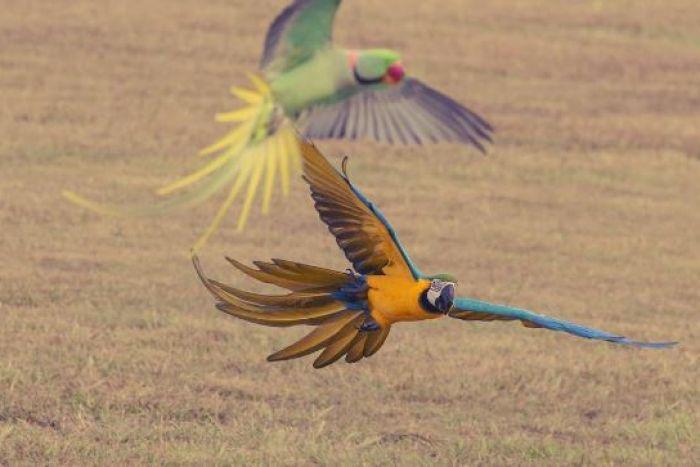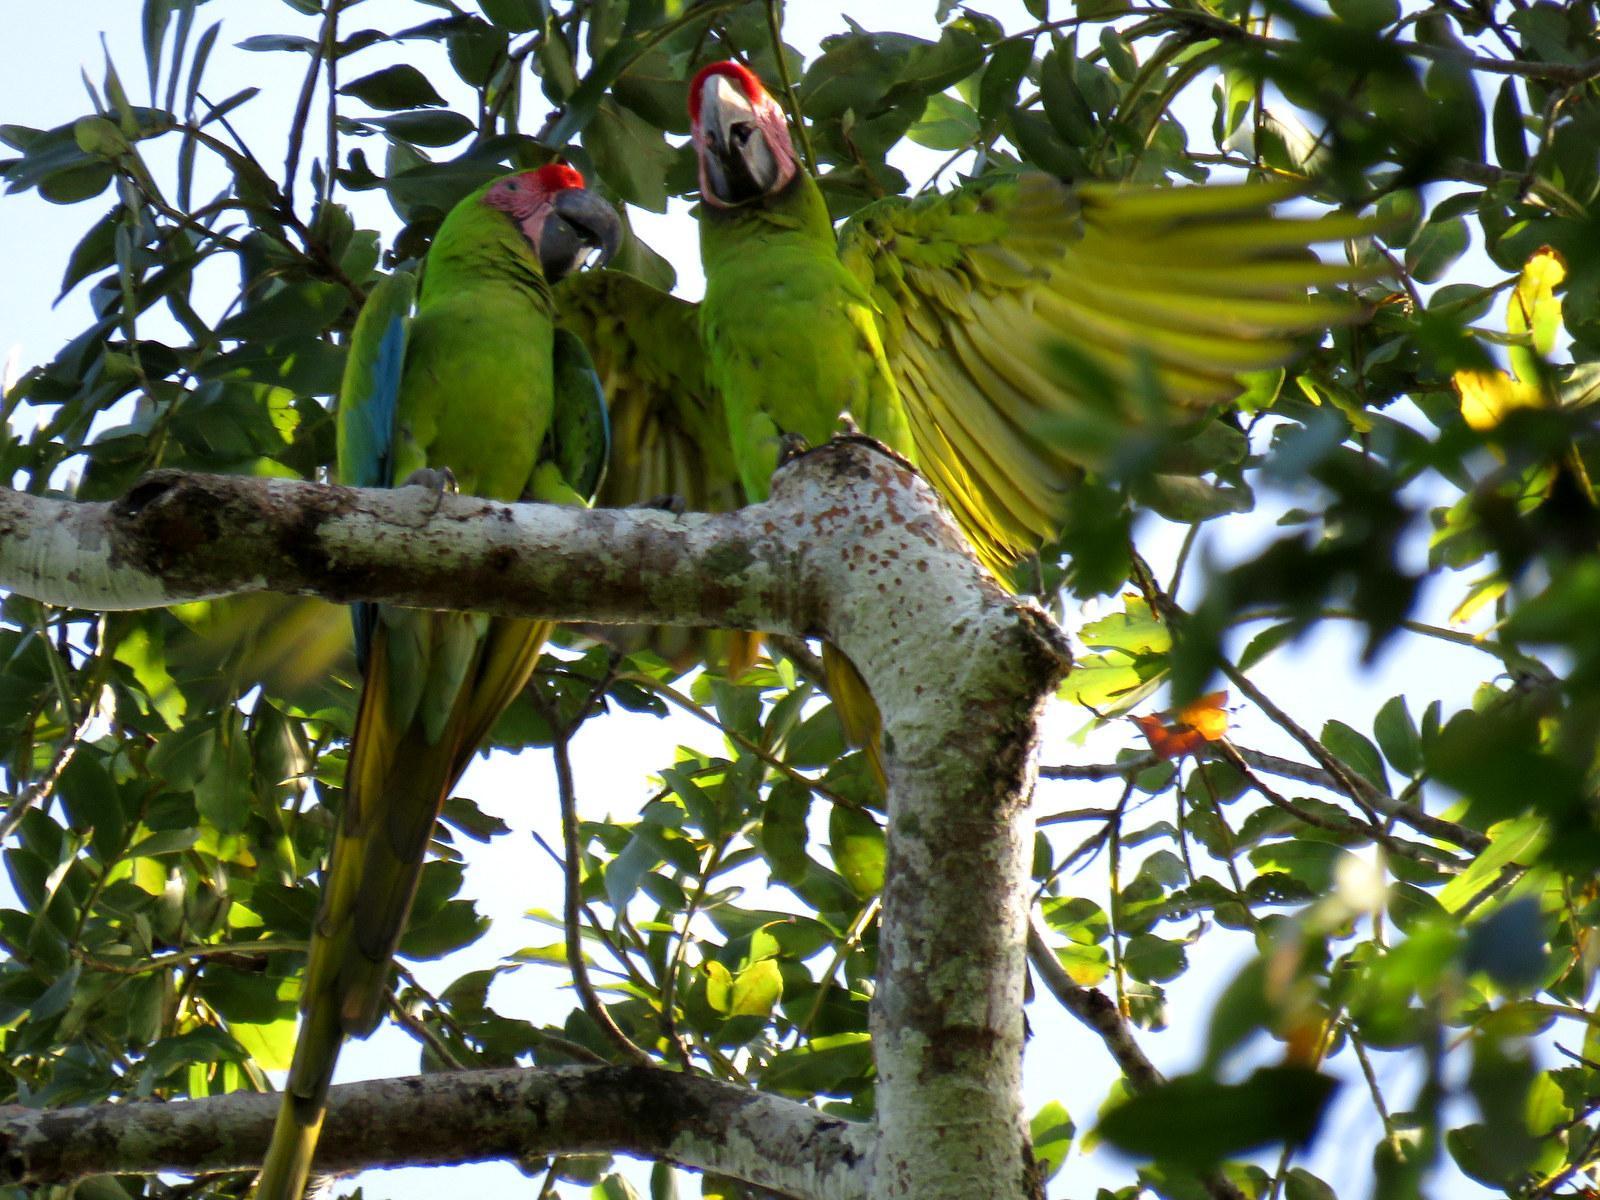The first image is the image on the left, the second image is the image on the right. For the images displayed, is the sentence "All birds are perched with wings folded, and at least one image shows multiple birds with the same coloring." factually correct? Answer yes or no. No. The first image is the image on the left, the second image is the image on the right. For the images shown, is this caption "Four colorful birds are perched outside." true? Answer yes or no. No. 